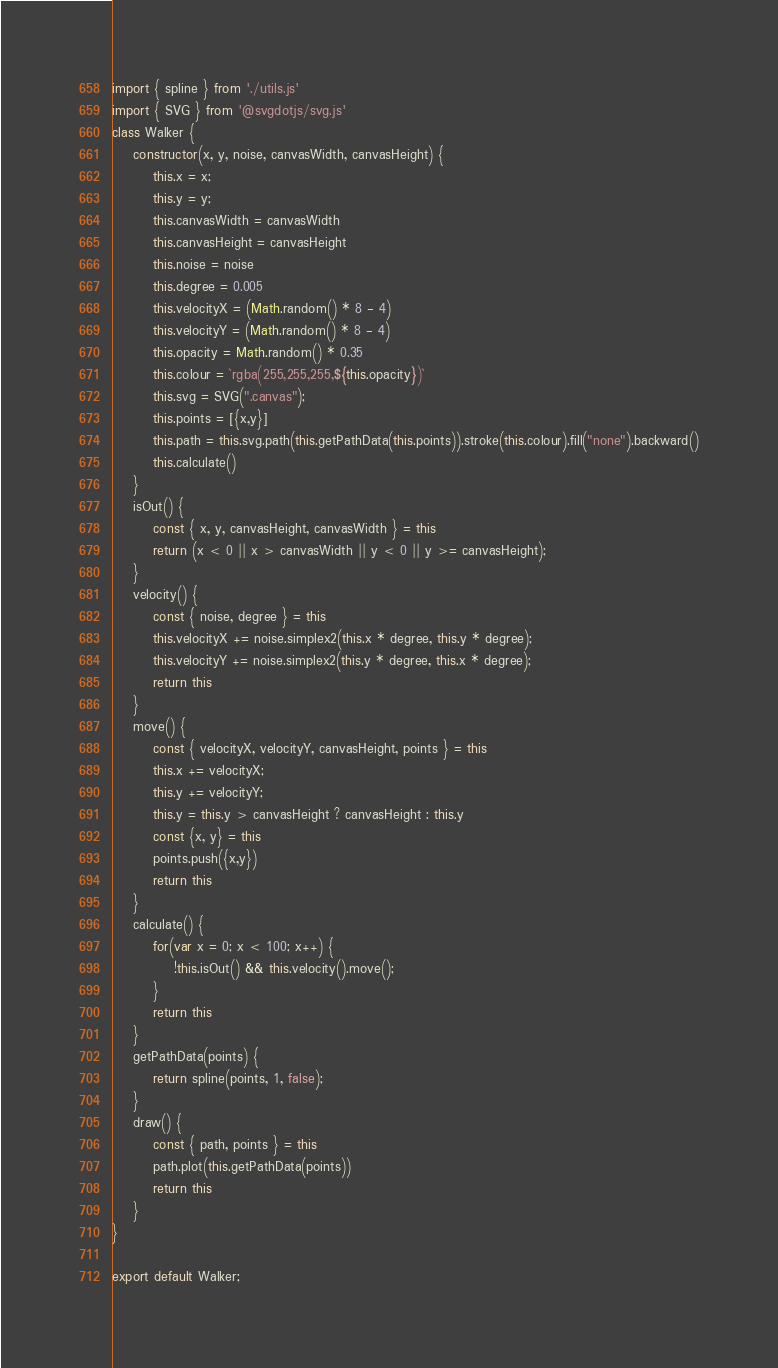Convert code to text. <code><loc_0><loc_0><loc_500><loc_500><_JavaScript_>import { spline } from './utils.js'
import { SVG } from '@svgdotjs/svg.js'
class Walker {
    constructor(x, y, noise, canvasWidth, canvasHeight) {
        this.x = x;
        this.y = y;
        this.canvasWidth = canvasWidth
        this.canvasHeight = canvasHeight
        this.noise = noise
        this.degree = 0.005
        this.velocityX = (Math.random() * 8 - 4)
        this.velocityY = (Math.random() * 8 - 4)
        this.opacity = Math.random() * 0.35
        this.colour = `rgba(255,255,255,${this.opacity})`
        this.svg = SVG(".canvas");
        this.points = [{x,y}]
        this.path = this.svg.path(this.getPathData(this.points)).stroke(this.colour).fill("none").backward()
        this.calculate()
    }
    isOut() {
        const { x, y, canvasHeight, canvasWidth } = this
        return (x < 0 || x > canvasWidth || y < 0 || y >= canvasHeight);
    }
    velocity() {
        const { noise, degree } = this
        this.velocityX += noise.simplex2(this.x * degree, this.y * degree);
        this.velocityY += noise.simplex2(this.y * degree, this.x * degree);
        return this
    }
    move() {
        const { velocityX, velocityY, canvasHeight, points } = this
        this.x += velocityX;
        this.y += velocityY;
        this.y = this.y > canvasHeight ? canvasHeight : this.y
        const {x, y} = this
        points.push({x,y})
        return this
    }
    calculate() {
        for(var x = 0; x < 100; x++) {
            !this.isOut() && this.velocity().move();
        }
        return this
    }
    getPathData(points) {
        return spline(points, 1, false);
    }
    draw() {
        const { path, points } = this
        path.plot(this.getPathData(points))
        return this
    }
}

export default Walker;</code> 